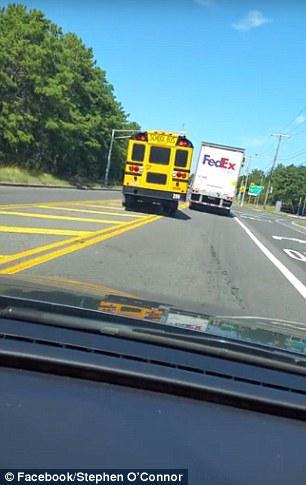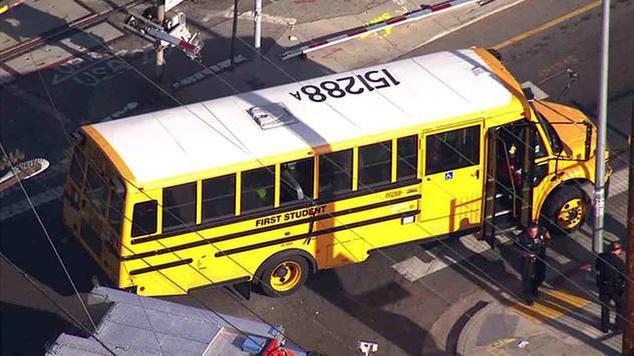The first image is the image on the left, the second image is the image on the right. Evaluate the accuracy of this statement regarding the images: "At least one of the buses' stop signs is visible.". Is it true? Answer yes or no. No. The first image is the image on the left, the second image is the image on the right. Examine the images to the left and right. Is the description "One image shows a flat-front yellow bus, and the other image shows a bus with a hood that projects below the windshield, and all buses are facing somewhat forward." accurate? Answer yes or no. No. 